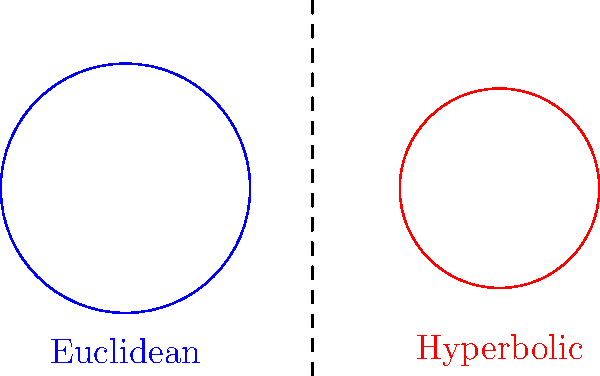In jiu-jitsu, understanding spatial relationships is crucial. Consider two circles with the same radius: one in Euclidean space and one in hyperbolic space (represented by the Poincaré disk model). If the area of the Euclidean circle is $A$, express the area of the hyperbolic circle in terms of $A$ and the hyperbolic radius $r$. Let's approach this step-by-step:

1) In Euclidean space, the area of a circle with radius $R$ is given by:
   $$A = \pi R^2$$

2) In hyperbolic space (Poincaré disk model), the area of a circle with hyperbolic radius $r$ is:
   $$A_h = 4\pi \sinh^2(\frac{r}{2})$$
   where $\sinh$ is the hyperbolic sine function.

3) We're told that both circles have the same radius, so let's set $R = r$.

4) We're also told that the area of the Euclidean circle is $A$. So:
   $$A = \pi R^2 = \pi r^2$$

5) Now, let's express the hyperbolic area in terms of $A$:
   $$A_h = 4\pi \sinh^2(\frac{r}{2})$$
   $$= 4\pi [\frac{e^{r/2} - e^{-r/2}}{2}]^2$$
   $$= \pi (e^r - 2 + e^{-r})$$
   $$= \pi (e^r + e^{-r} - 2)$$

6) We can express $r$ in terms of $A$:
   $$r = \sqrt{\frac{A}{\pi}}$$

7) Substituting this into our hyperbolic area formula:
   $$A_h = \pi (e^{\sqrt{A/\pi}} + e^{-\sqrt{A/\pi}} - 2)$$

This gives us the area of the hyperbolic circle in terms of $A$ and $r$.
Answer: $A_h = \pi (e^{\sqrt{A/\pi}} + e^{-\sqrt{A/\pi}} - 2)$ 